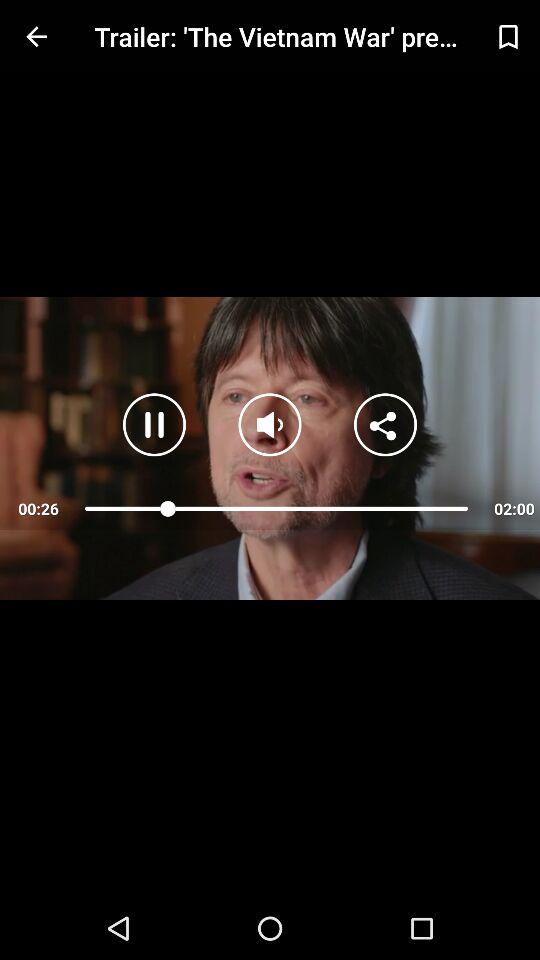How many seconds have elapsed in the video?
Answer the question using a single word or phrase. 26 